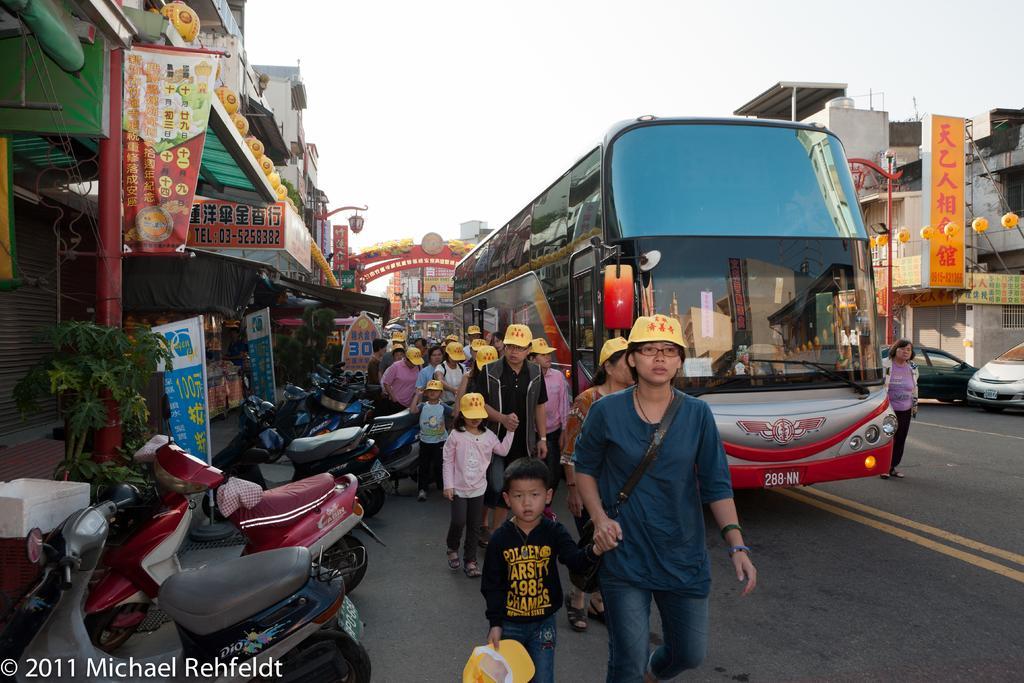How would you summarize this image in a sentence or two? In the image in the center we can see one bus and few people were walking and wearing yellow cap. On the left side we can see building,shops,banners,sign boards,balloons,lights,plants,bikes,boxes,water mark and few other objects. In the background we can see sky,clouds,arch,building,wall,poles,balloons,banners,sign boards and few vehicles on the road. 